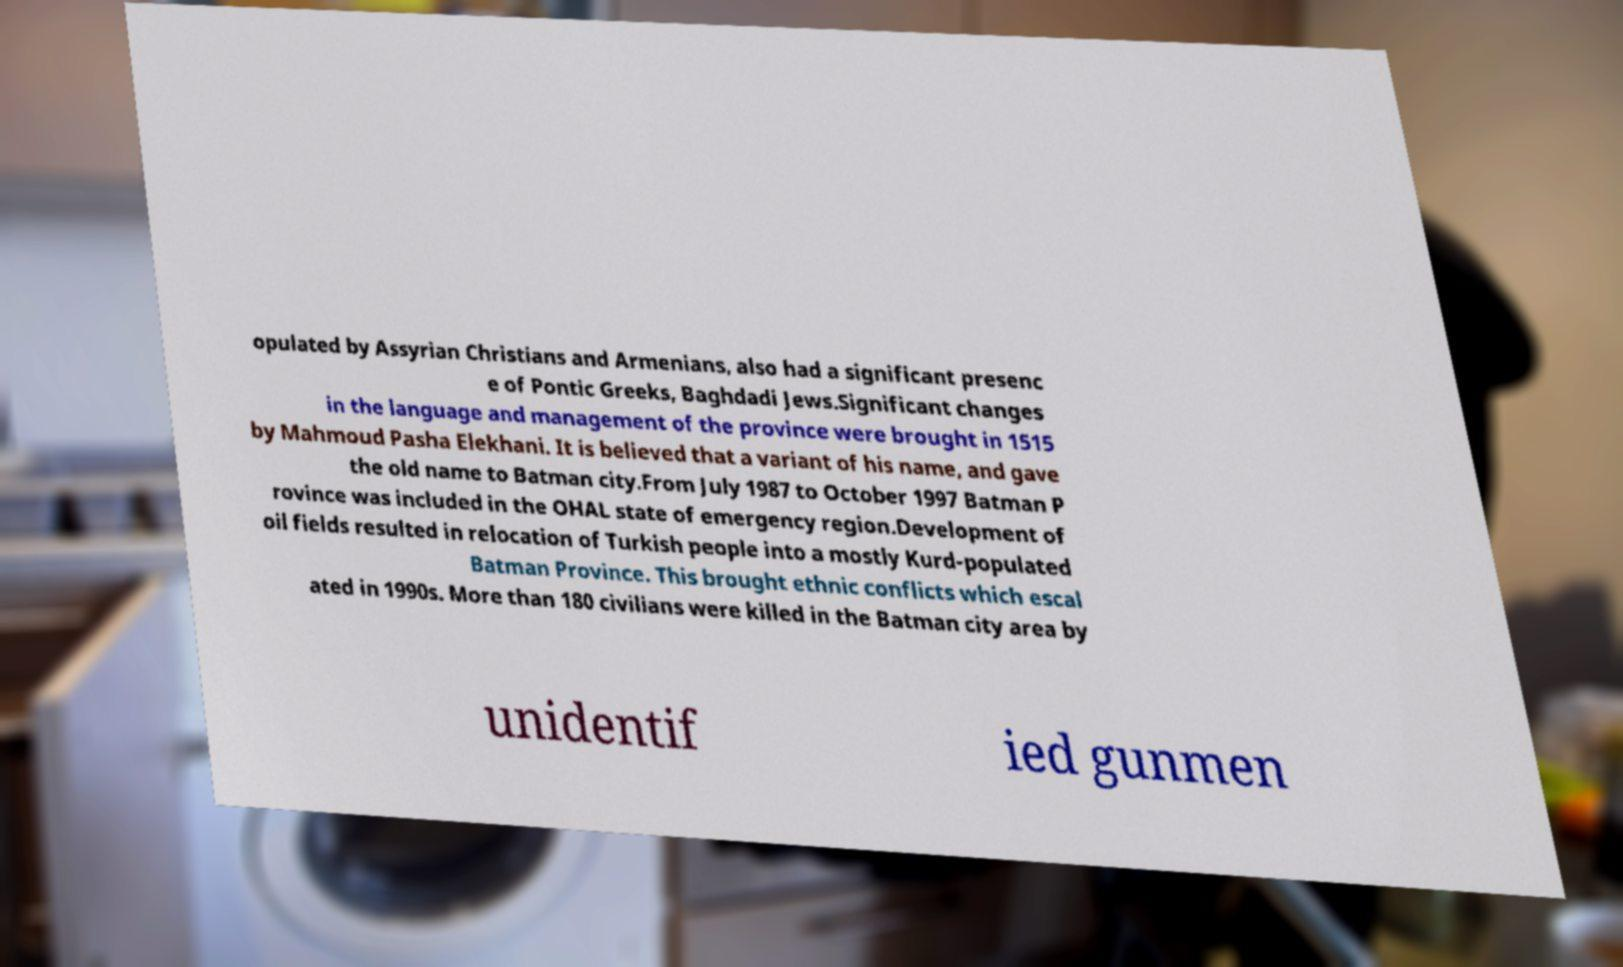I need the written content from this picture converted into text. Can you do that? opulated by Assyrian Christians and Armenians, also had a significant presenc e of Pontic Greeks, Baghdadi Jews.Significant changes in the language and management of the province were brought in 1515 by Mahmoud Pasha Elekhani. It is believed that a variant of his name, and gave the old name to Batman city.From July 1987 to October 1997 Batman P rovince was included in the OHAL state of emergency region.Development of oil fields resulted in relocation of Turkish people into a mostly Kurd-populated Batman Province. This brought ethnic conflicts which escal ated in 1990s. More than 180 civilians were killed in the Batman city area by unidentif ied gunmen 